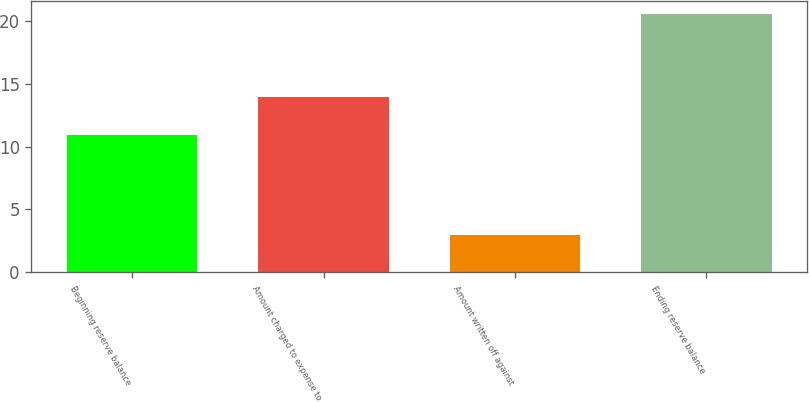Convert chart. <chart><loc_0><loc_0><loc_500><loc_500><bar_chart><fcel>Beginning reserve balance<fcel>Amount charged to expense to<fcel>Amount written off against<fcel>Ending reserve balance<nl><fcel>10.9<fcel>13.9<fcel>3<fcel>20.5<nl></chart> 